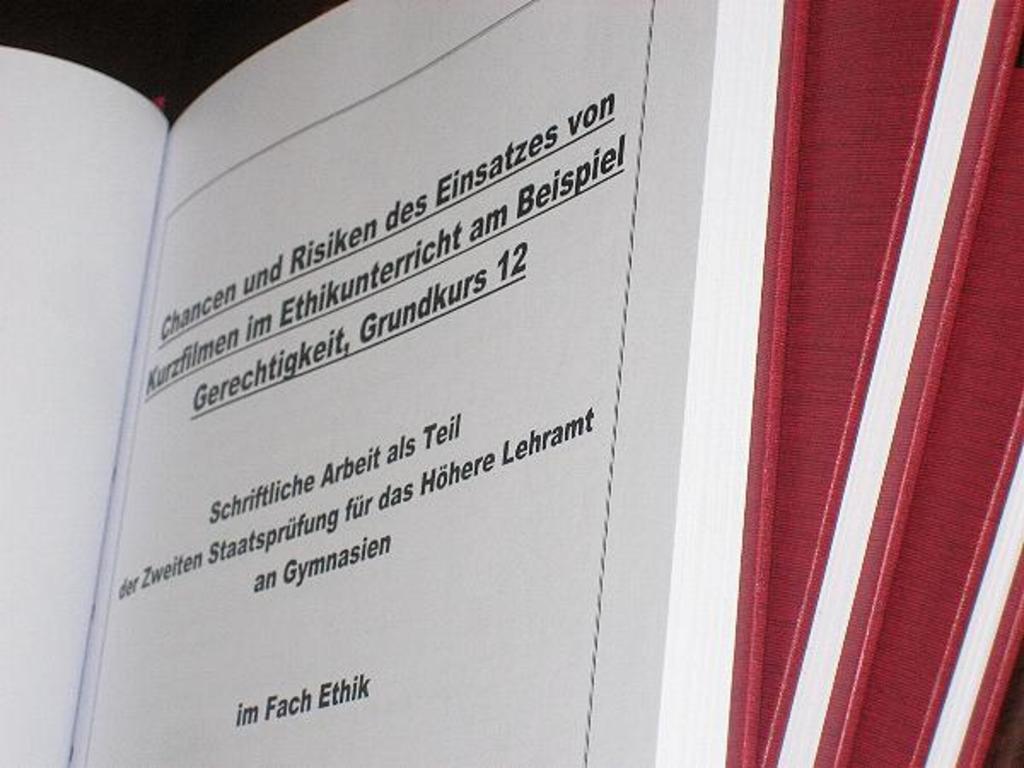What is the name of the book?
Make the answer very short. Unanswerable. 